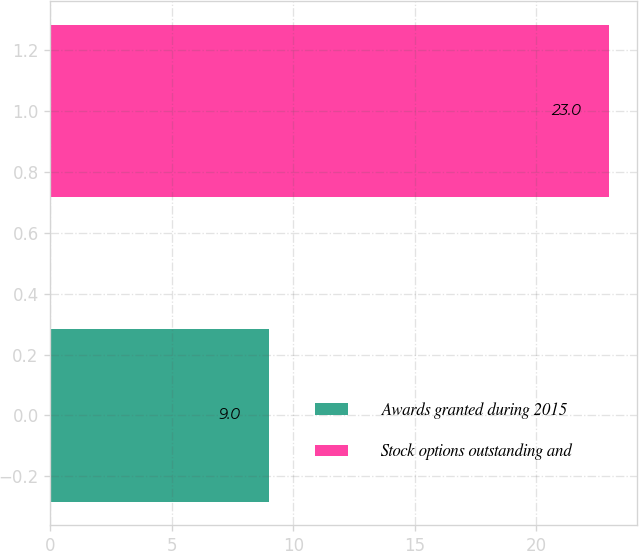Convert chart. <chart><loc_0><loc_0><loc_500><loc_500><bar_chart><fcel>Awards granted during 2015<fcel>Stock options outstanding and<nl><fcel>9<fcel>23<nl></chart> 